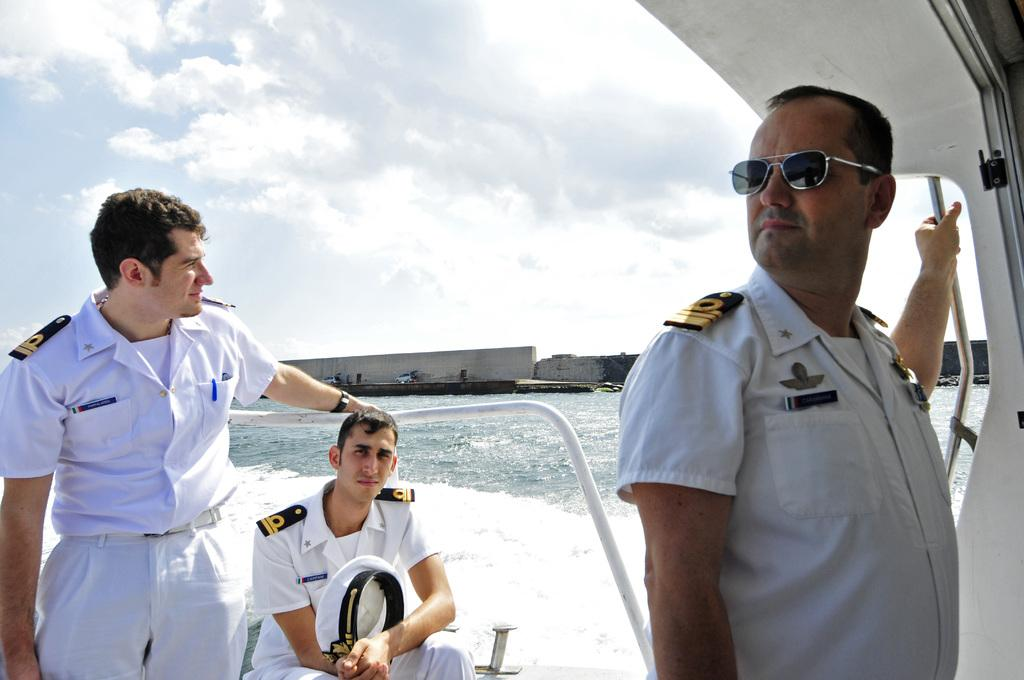What is the person in the image doing? There is a person sitting on a boat in the image. How many other people are on the boat? There are two persons standing on the boat. Where is the boat located? The boat is on the water. What can be seen in the background of the image? There are vehicles, a wall, and the sky visible in the background of the image. What type of jewel is the ghost holding in the image? There is no ghost or jewel present in the image. 